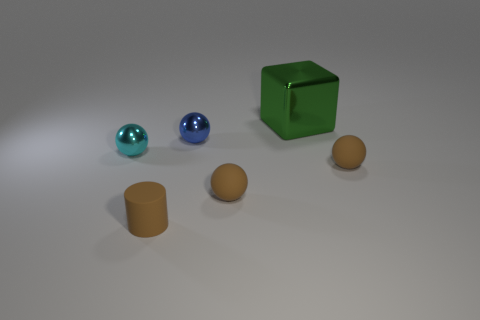Are there more brown objects that are behind the small rubber cylinder than tiny shiny objects?
Ensure brevity in your answer.  No. How many matte balls have the same size as the brown rubber cylinder?
Your response must be concise. 2. What number of tiny objects are rubber balls or purple metal spheres?
Keep it short and to the point. 2. How many tiny green blocks are there?
Ensure brevity in your answer.  0. Is the number of tiny blue spheres to the left of the green object the same as the number of large things that are to the left of the small cyan sphere?
Keep it short and to the point. No. There is a cyan metallic ball; are there any big green metallic blocks to the right of it?
Ensure brevity in your answer.  Yes. There is a shiny object that is in front of the tiny blue ball; what color is it?
Offer a very short reply. Cyan. The brown object right of the metallic object right of the small blue metallic object is made of what material?
Keep it short and to the point. Rubber. Is the number of tiny brown rubber objects that are on the right side of the cylinder less than the number of rubber cylinders that are behind the tiny cyan sphere?
Offer a terse response. No. What number of blue objects are either small spheres or metal cubes?
Your answer should be very brief. 1. 